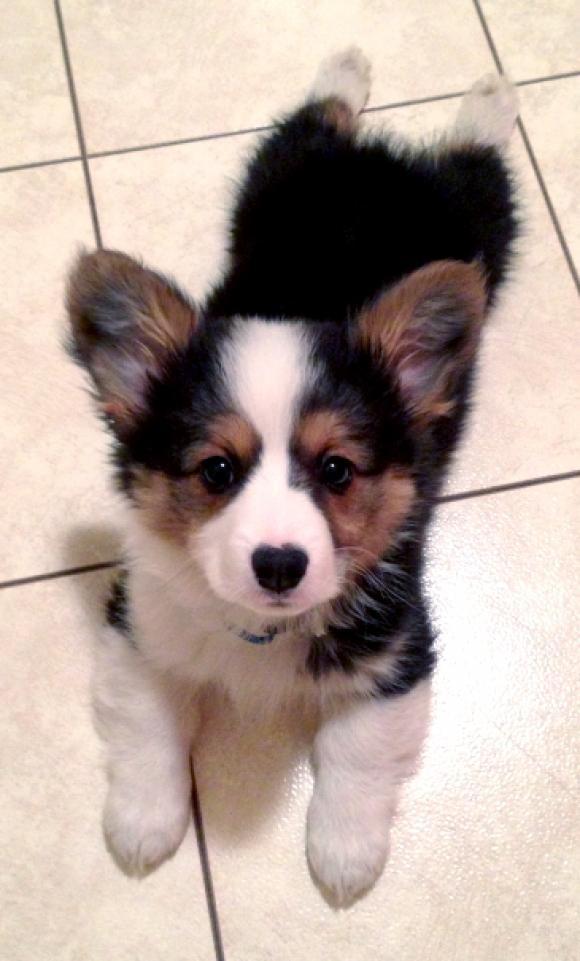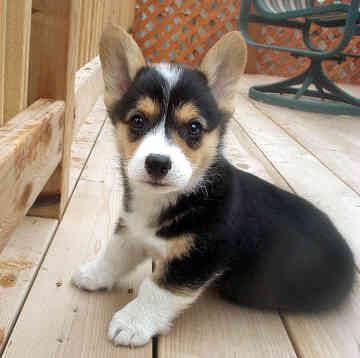The first image is the image on the left, the second image is the image on the right. For the images displayed, is the sentence "A small dog with its tongue hanging out is on a light colored chair." factually correct? Answer yes or no. No. The first image is the image on the left, the second image is the image on the right. Examine the images to the left and right. Is the description "One puppy has their tongue out." accurate? Answer yes or no. No. 